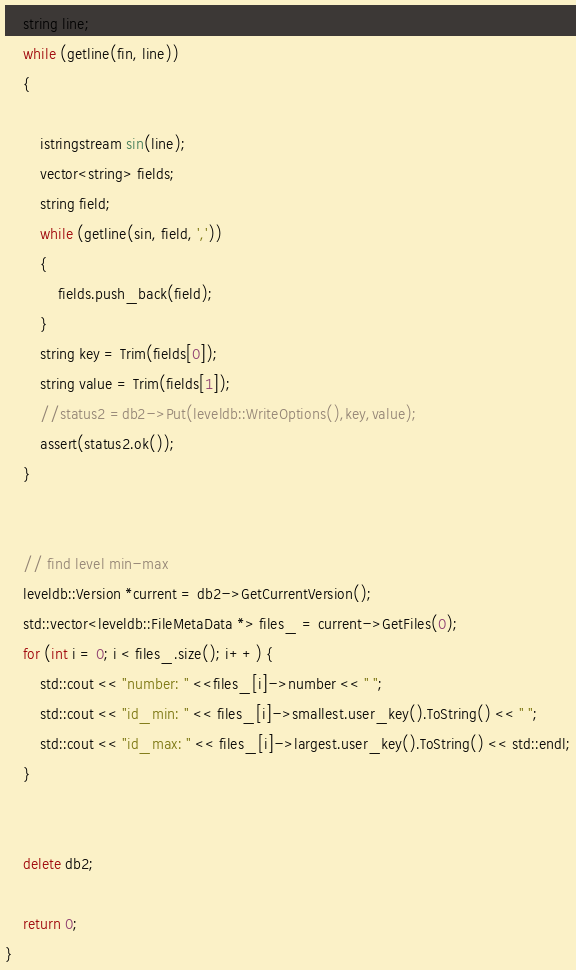<code> <loc_0><loc_0><loc_500><loc_500><_C++_>    string line;
    while (getline(fin, line))
    {

        istringstream sin(line);
        vector<string> fields;
        string field;
        while (getline(sin, field, ','))
        {
            fields.push_back(field);
        }
        string key = Trim(fields[0]);
        string value = Trim(fields[1]);
        //status2 =db2->Put(leveldb::WriteOptions(),key,value);
        assert(status2.ok());
    }


    // find level min-max
    leveldb::Version *current = db2->GetCurrentVersion();
    std::vector<leveldb::FileMetaData *> files_ = current->GetFiles(0);
    for (int i = 0; i < files_.size(); i++) {
        std::cout << "number: " <<files_[i]->number << " ";
        std::cout << "id_min: " << files_[i]->smallest.user_key().ToString() << " ";
        std::cout << "id_max: " << files_[i]->largest.user_key().ToString() << std::endl;
    }


    delete db2;

    return 0;
}
</code> 